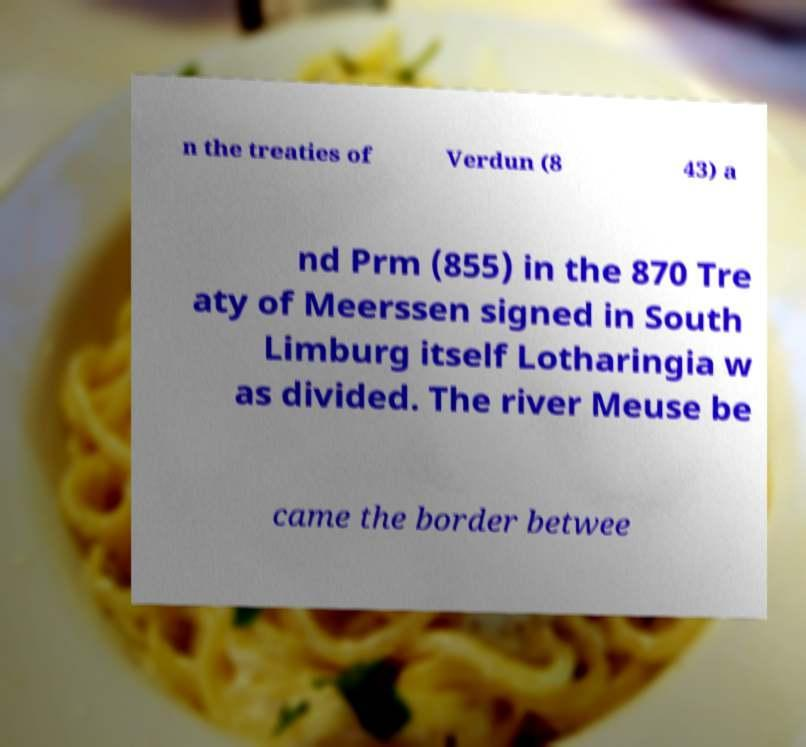There's text embedded in this image that I need extracted. Can you transcribe it verbatim? n the treaties of Verdun (8 43) a nd Prm (855) in the 870 Tre aty of Meerssen signed in South Limburg itself Lotharingia w as divided. The river Meuse be came the border betwee 